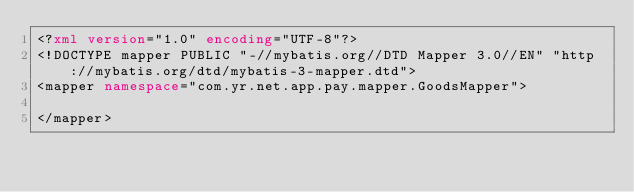Convert code to text. <code><loc_0><loc_0><loc_500><loc_500><_XML_><?xml version="1.0" encoding="UTF-8"?>
<!DOCTYPE mapper PUBLIC "-//mybatis.org//DTD Mapper 3.0//EN" "http://mybatis.org/dtd/mybatis-3-mapper.dtd">
<mapper namespace="com.yr.net.app.pay.mapper.GoodsMapper">

</mapper>
</code> 